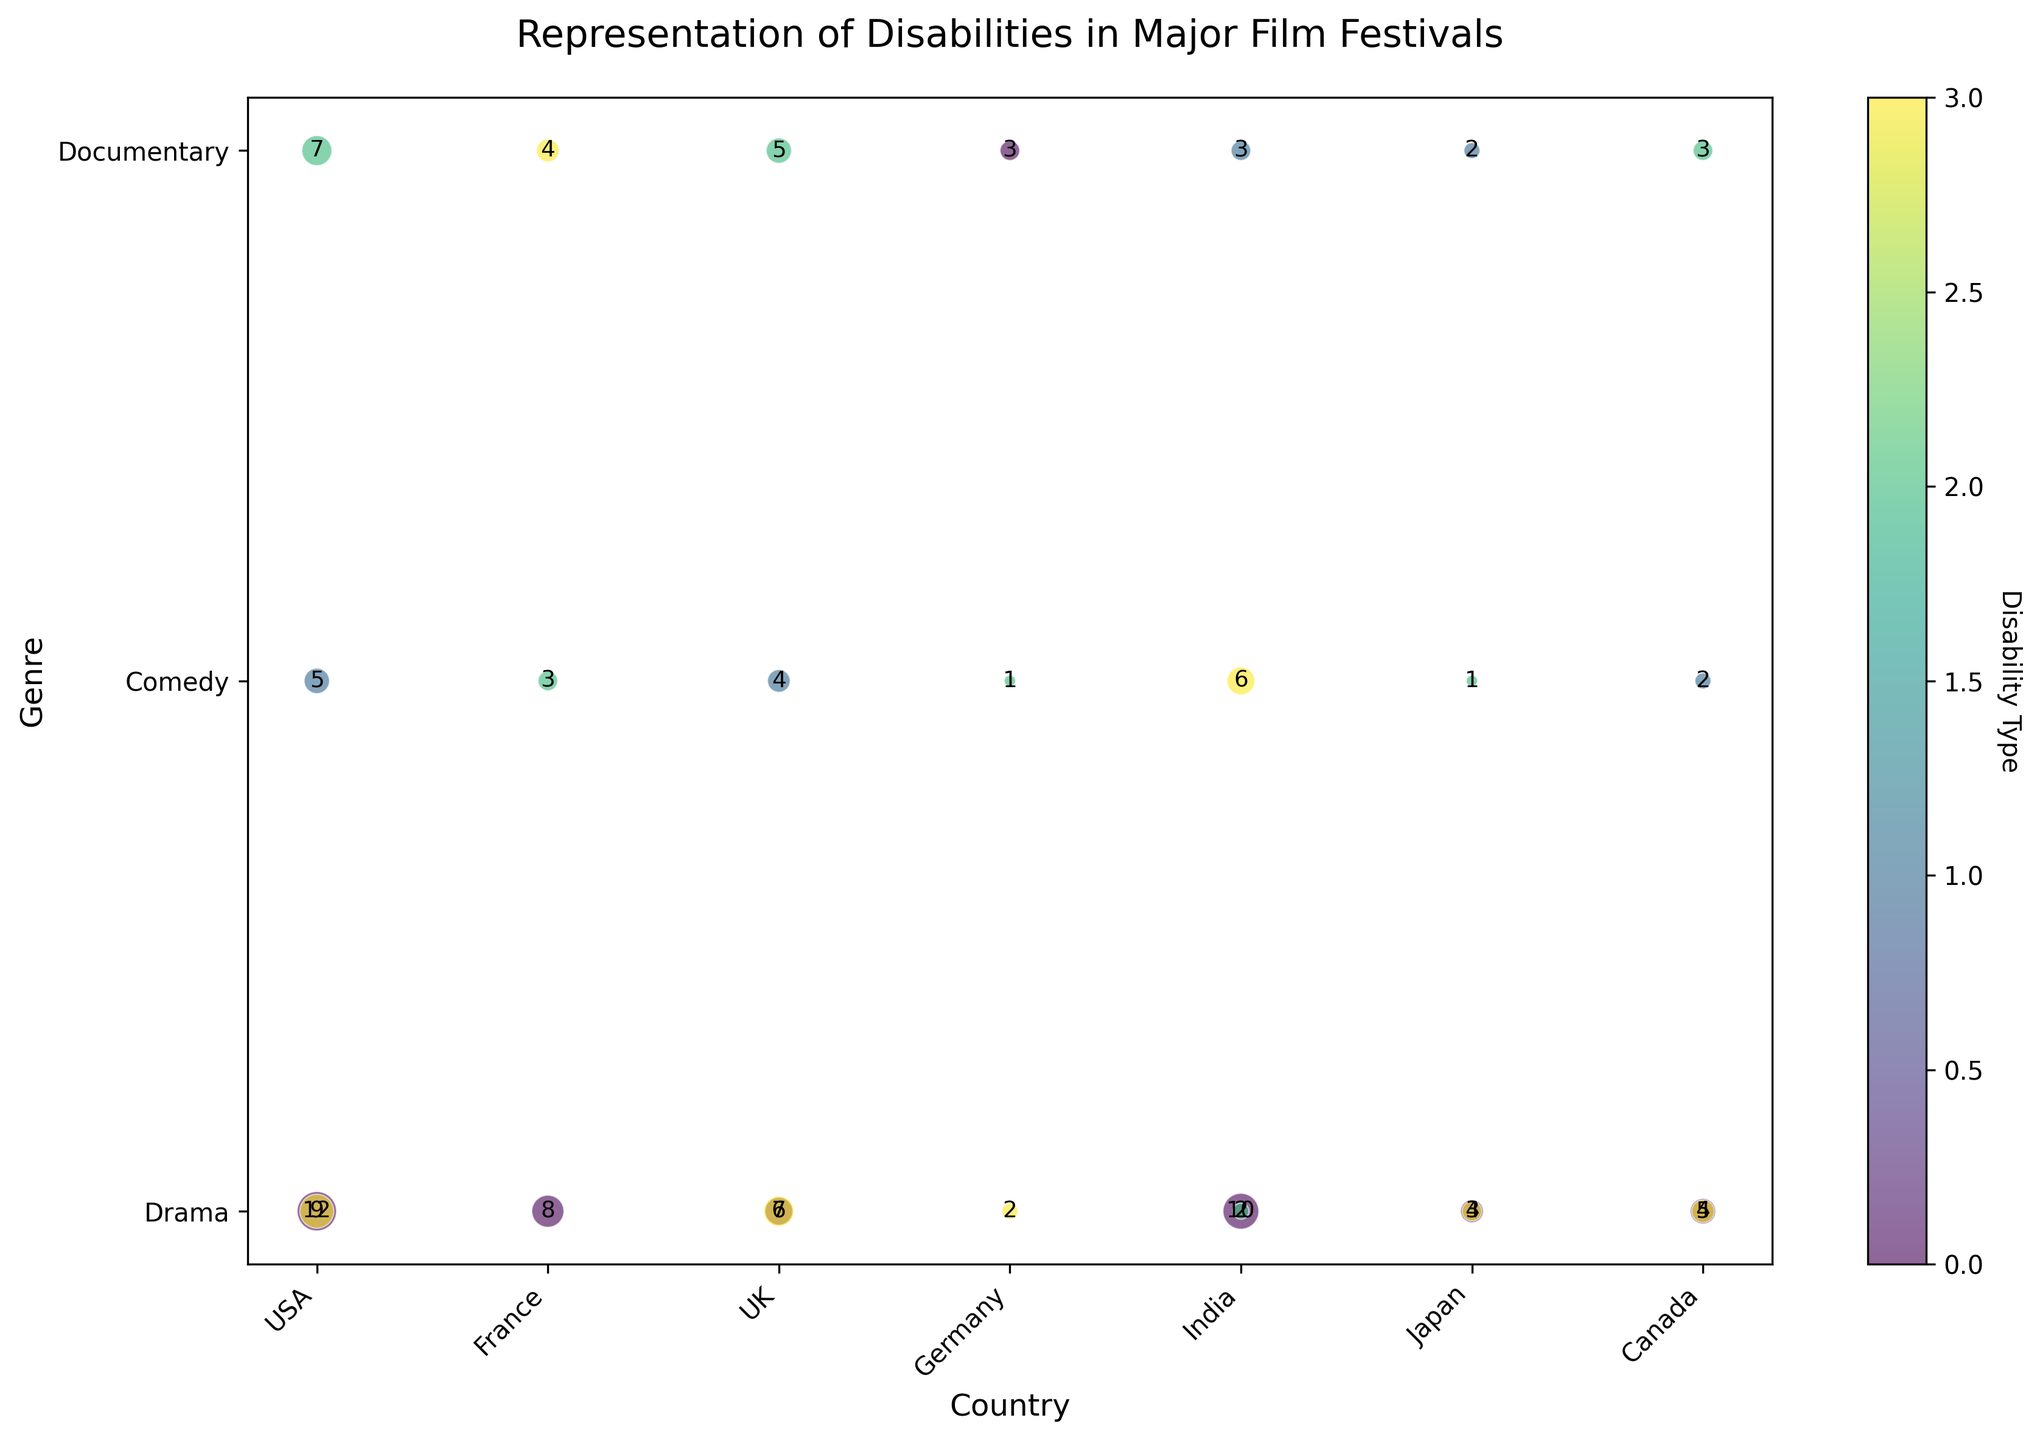Which country has the highest representation of physical disabilities in dramas? Look for the largest bubble in the drama genre (y-axis) under the physical disability category (color) and identify its country (x-axis). The biggest bubble is located in the U.S. section.
Answer: USA How many total films from Germany portray disabilities? Sum all the counts for Germany across all genres and disabilities: 3 (documentary, physical) + 2 (drama, mental) + 1 (comedy, sensory) = 6.
Answer: 6 Which genre in France has the least representation of disabilities? Look for the smallest bubbles in the France section and identify their corresponding genre. The smallest bubble is in the comedy genre under the sensory disability category.
Answer: Comedy What is the most frequently portrayed disability type in Canada's films? Compare the sizes of the bubbles in Canada's section across genres to see which disability has the biggest bubble. The largest bubble is under the drama genre, physical disability category.
Answer: Physical How does the representation of mental disabilities in Japanese dramas compare to that in Indian dramas? Compare the size of the bubbles for mental disabilities in the drama genre between Japan and India. Japan has a smaller bubble with a count of 3, while India has a count of 2.
Answer: Japan has slightly higher representation What is the ratio of sensory to cognitive disability portrayals in UK documentaries? Find the bubble sizes for sensory and cognitive disabilities in UK documentaries and then calculate the ratio. Sensory has a count of 5 and cognitive has a count of 4. Ratio = 5:4
Answer: 5:4 Which country has the lowest representation of cognitive disabilities in documentaries? Look for the smallest or missing bubbles in the documentary genre for cognitive disabilities and identify the country. The smallest bubbles are in Japan and India, both with a count of 2.
Answer: Japan and India Among the genres in the USA, which genre has the highest average representation of disabilities? Calculate the average count for each genre in the USA section:
Drama: (12 + 9)/2 = 10.5
Comedy: 5/1 = 5
Documentary: 7/1 = 7. Drama has the highest average of 10.5
Answer: Drama 